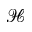<formula> <loc_0><loc_0><loc_500><loc_500>\mathcal { H }</formula> 